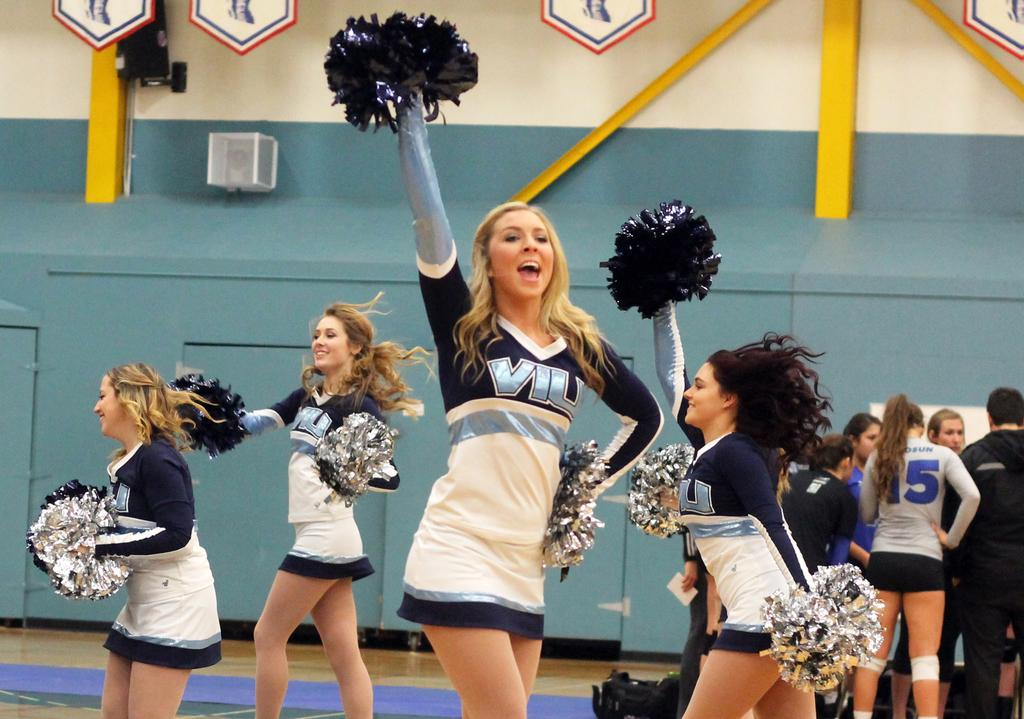<image>
Offer a succinct explanation of the picture presented. Sports cheerleaders in navy and white uniforms with the letters VIU in light blue across the front. 